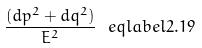Convert formula to latex. <formula><loc_0><loc_0><loc_500><loc_500>\frac { ( d p ^ { 2 } + d q ^ { 2 } ) } { E ^ { 2 } } \ e q l a b e l { 2 . 1 9 }</formula> 